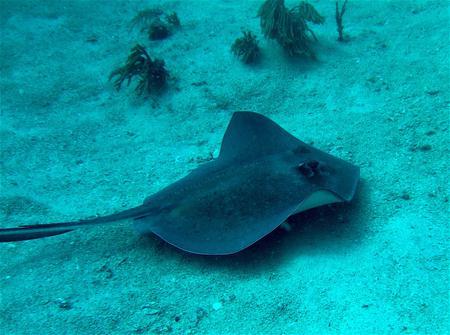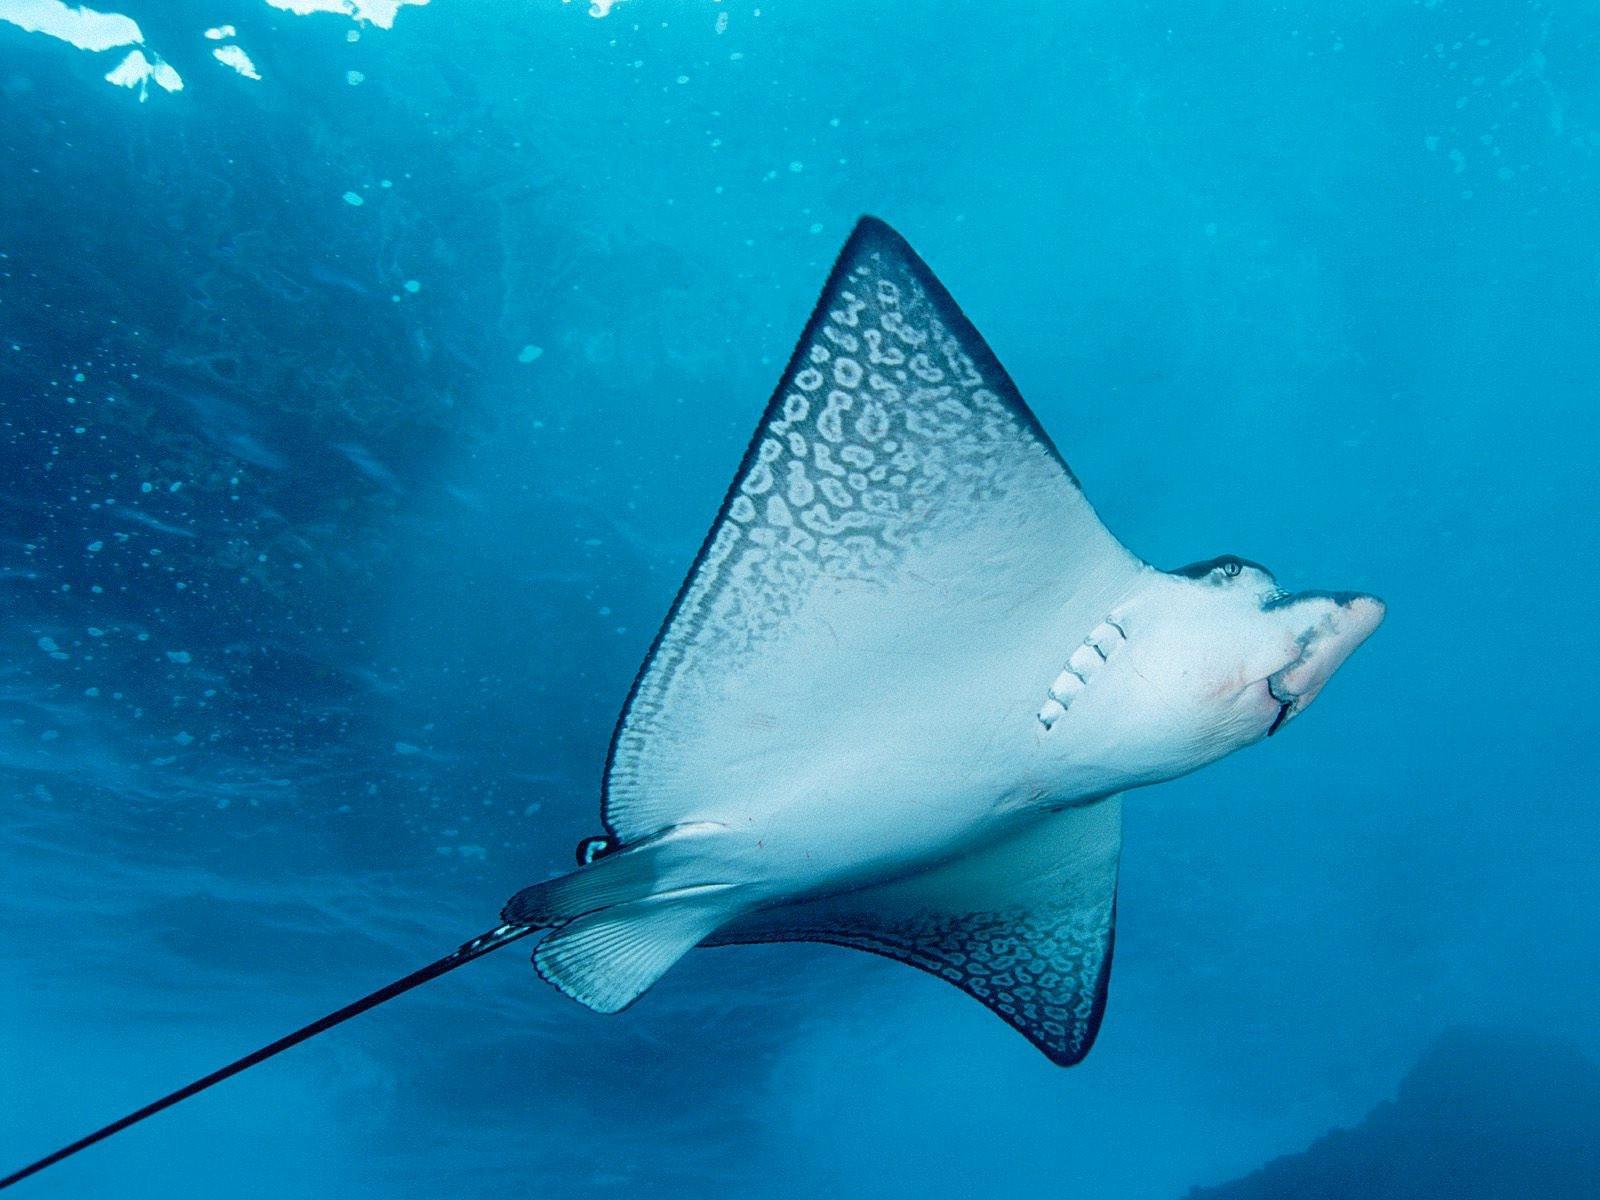The first image is the image on the left, the second image is the image on the right. Assess this claim about the two images: "An image shows exactly two dark stingrays, including at least one that is nearly black.". Correct or not? Answer yes or no. No. 